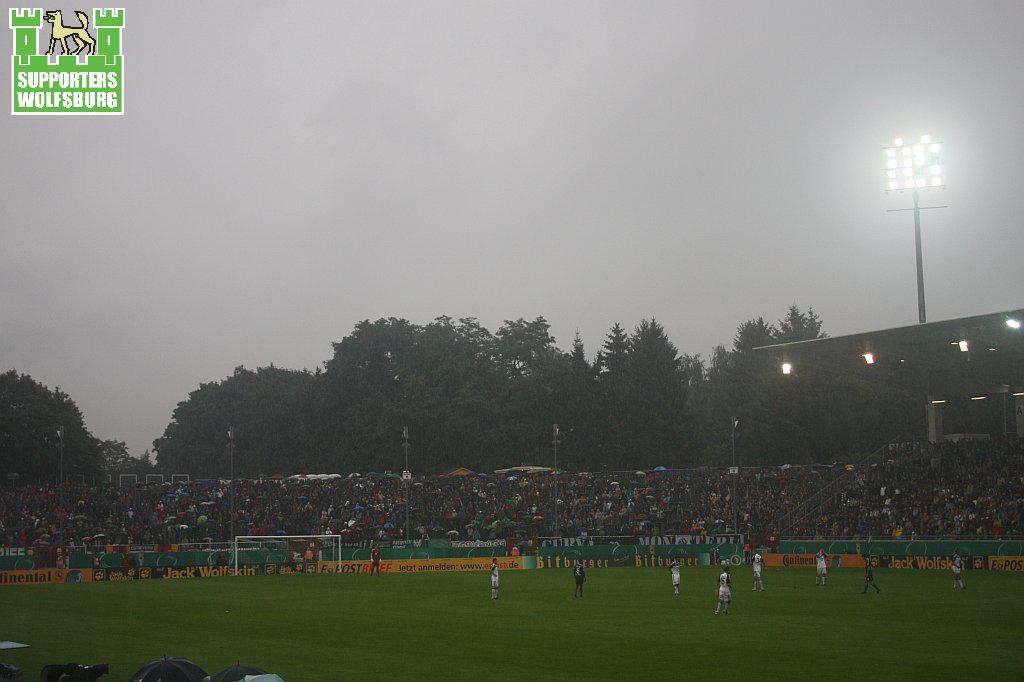Can you describe this image briefly? In this image we can see sky, flood lights, trees, poles, spectators, parasols, advertisement boards and persons standing in the ground. 